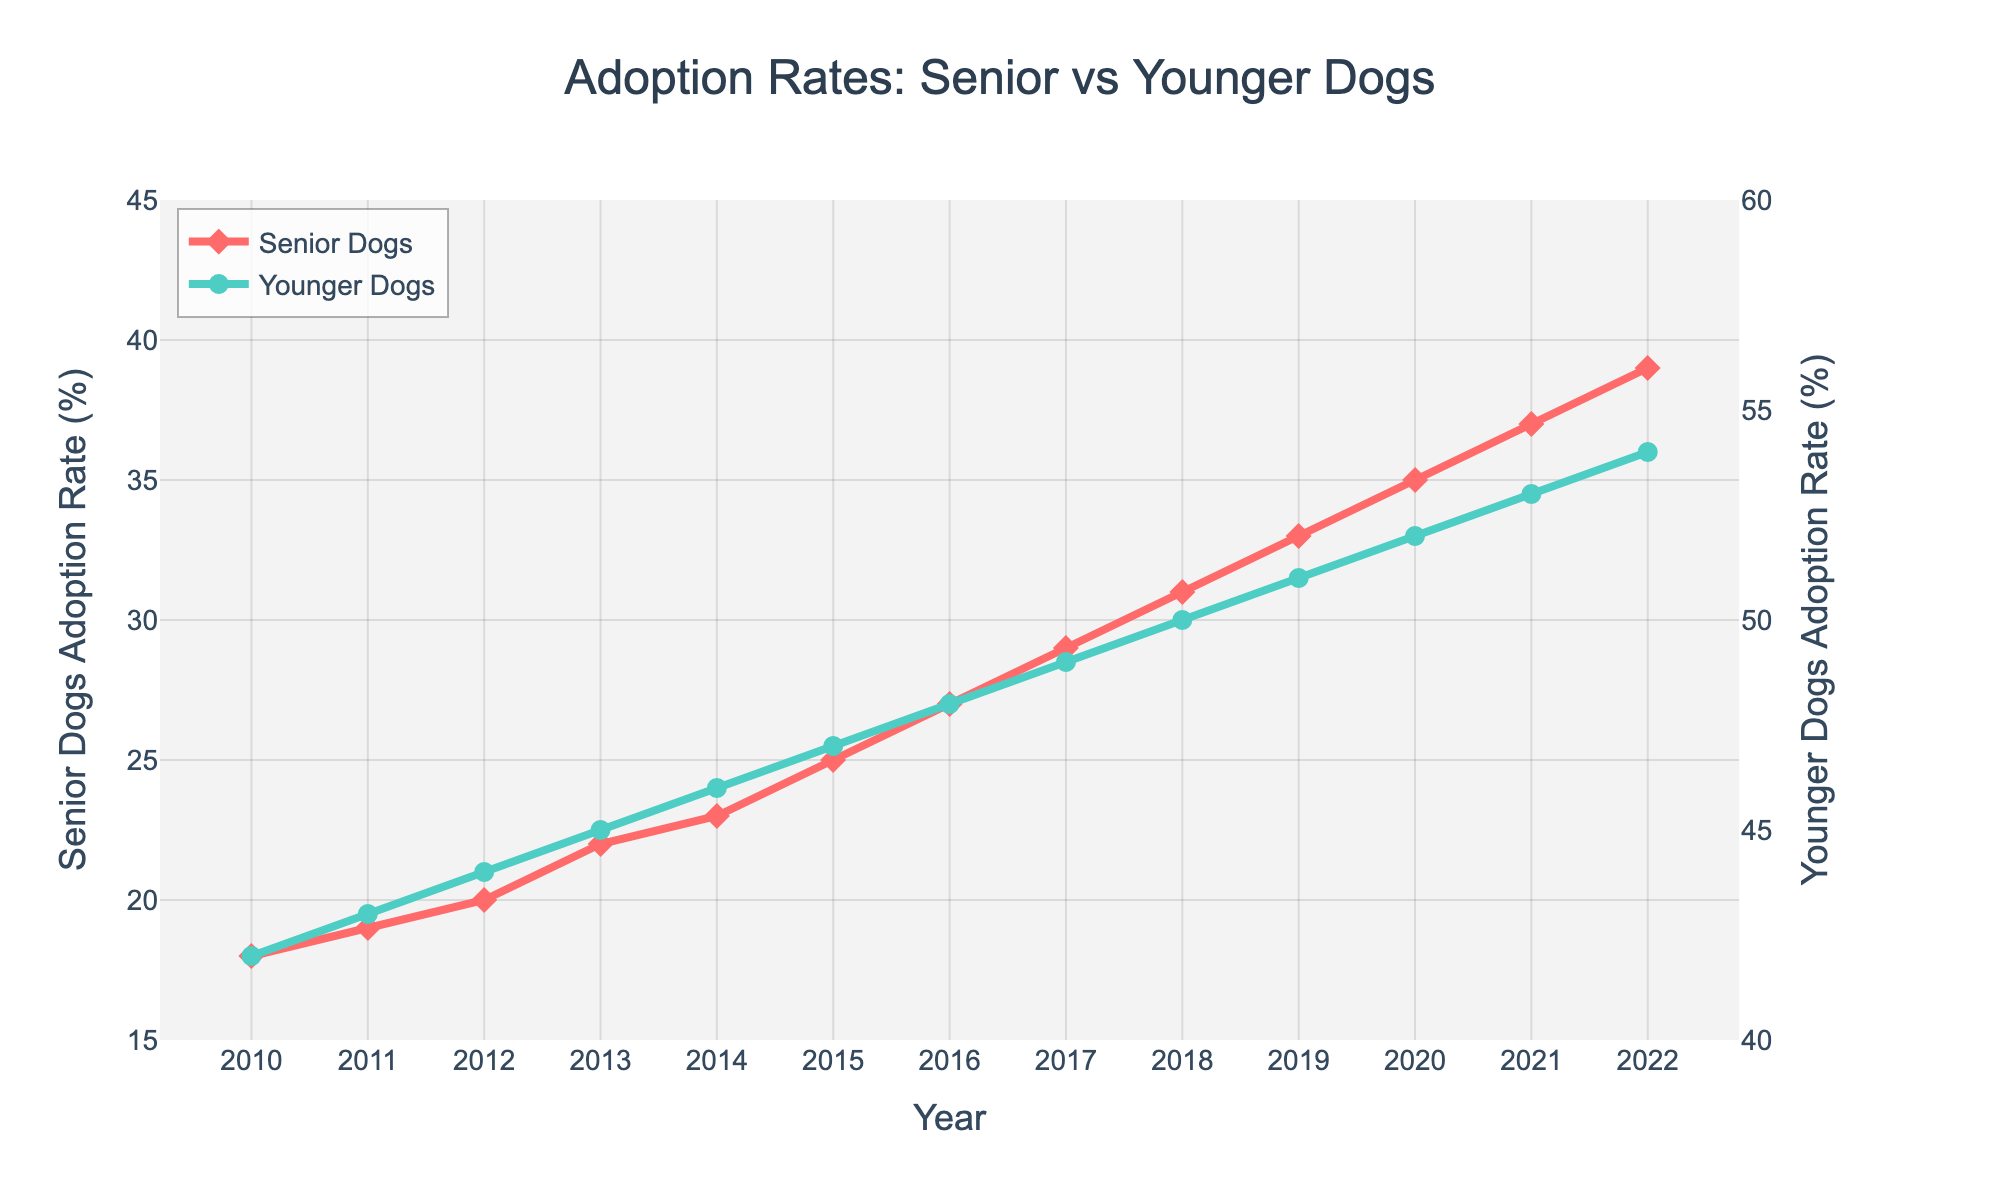What's the average adoption rate for senior dogs in 2016 and 2017? The adoption rates for senior dogs in 2016 and 2017 are 27% and 29%, respectively. The average is calculated as (27 + 29) / 2 = 28
Answer: 28 Which year showed the greatest annual increase in adoption rates for senior dogs? The adoption rates are consistently increasing for senior dogs but the biggest annual increase can be seen between years 2011 and 2012 with a jump from 19% to 20%, an increase of 1%. By comparing subsequent years, no other year shows a bigger annual change.
Answer: 2011-2012 How do the adoption rates for senior dogs in 2010 compare to the younger dogs in the same year? In 2010, the adoption rate for senior dogs was 18%, whereas for younger dogs it was 42%. The adoption rate for younger dogs was significantly higher.
Answer: Younger dogs had a higher adoption rate By how many percentage points did the adoption rate for younger dogs increase from 2010 to 2022? The adoption rates for younger dogs were 42% in 2010 and 54% in 2022. The increase is calculated as 54 - 42 = 12 percentage points.
Answer: 12 In which year did senior dogs achieve an adoption rate above 30% for the first time? Reviewing the adoption rates for senior dogs by year, 31% was first achieved in 2018.
Answer: 2018 What is the difference in adoption rates between senior and younger dogs in 2022? In 2022, the adoption rates are 39% for senior dogs and 54% for younger dogs. The difference is calculated as 54 - 39 = 15 percentage points.
Answer: 15 What trend can be observed in the adoption rates for senior dogs from 2010 to 2022? The adoption rates for senior dogs show a consistent upward trend from 18% in 2010 to 39% in 2022. This indicates a growing preference or improvement in adopting senior dogs over the years.
Answer: Upward trend What is the combined adoption rate for both senior and younger dogs in 2015? The adoption rates for senior dogs and younger dogs in 2015 are 25% and 47%, respectively. The combined rate is calculated as 25 + 47 = 72%.
Answer: 72 What is the median adoption rate for younger dogs over the years shown? To find the median, list the adoption rates for younger dogs in ascending order: 42%, 43%, 44%, 45%, 46%, 47%, 48%, 49%, 50%, 51%, 52%, 53%, 54%. The median value, which is the middle number in an ordered list, is the 7th value: 48%.
Answer: 48 